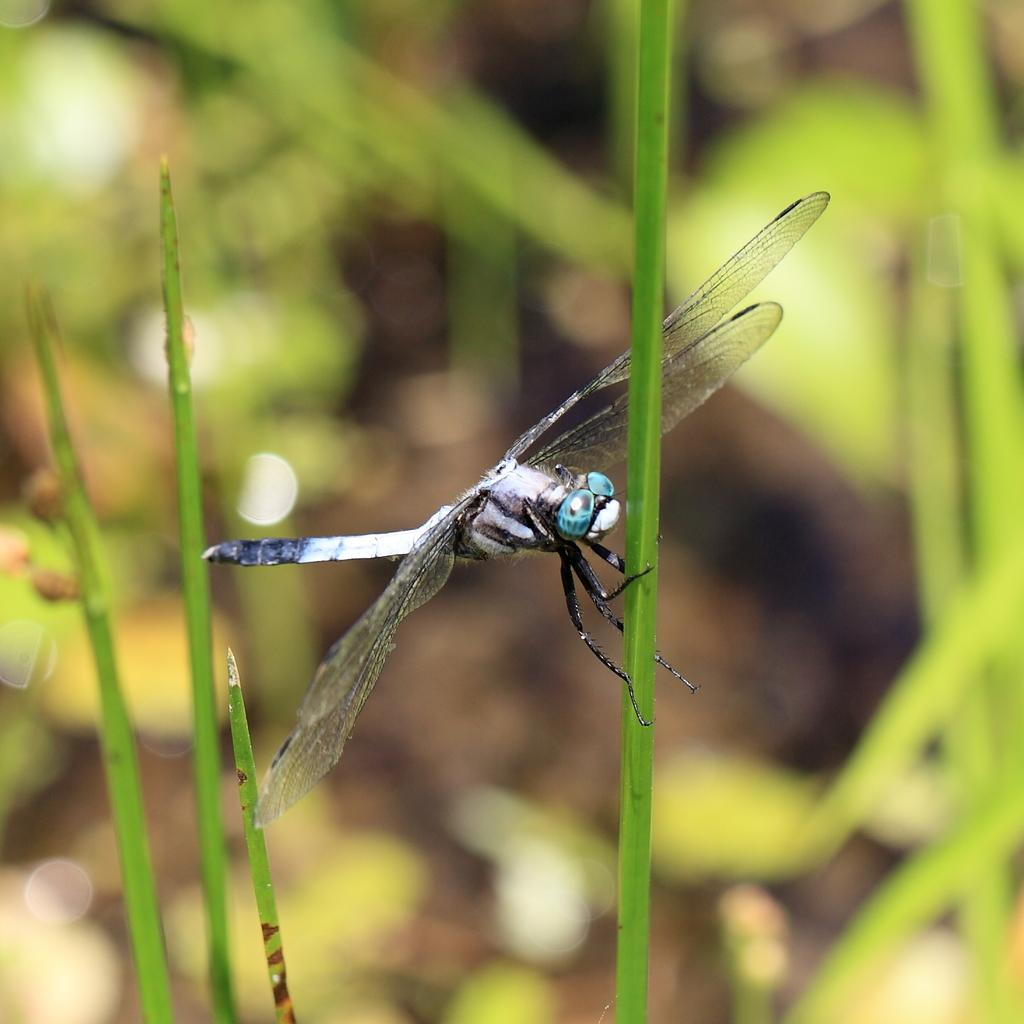What insect can be seen in the image? There is a dragonfly on a plant in the image. What type of vegetation is visible in the image? There is grass visible in the image. Can you describe the background of the image? The background of the image is blurred. Where is the throne located in the image? There is no throne present in the image. What type of desk can be seen in the image? There is no desk present in the image. 